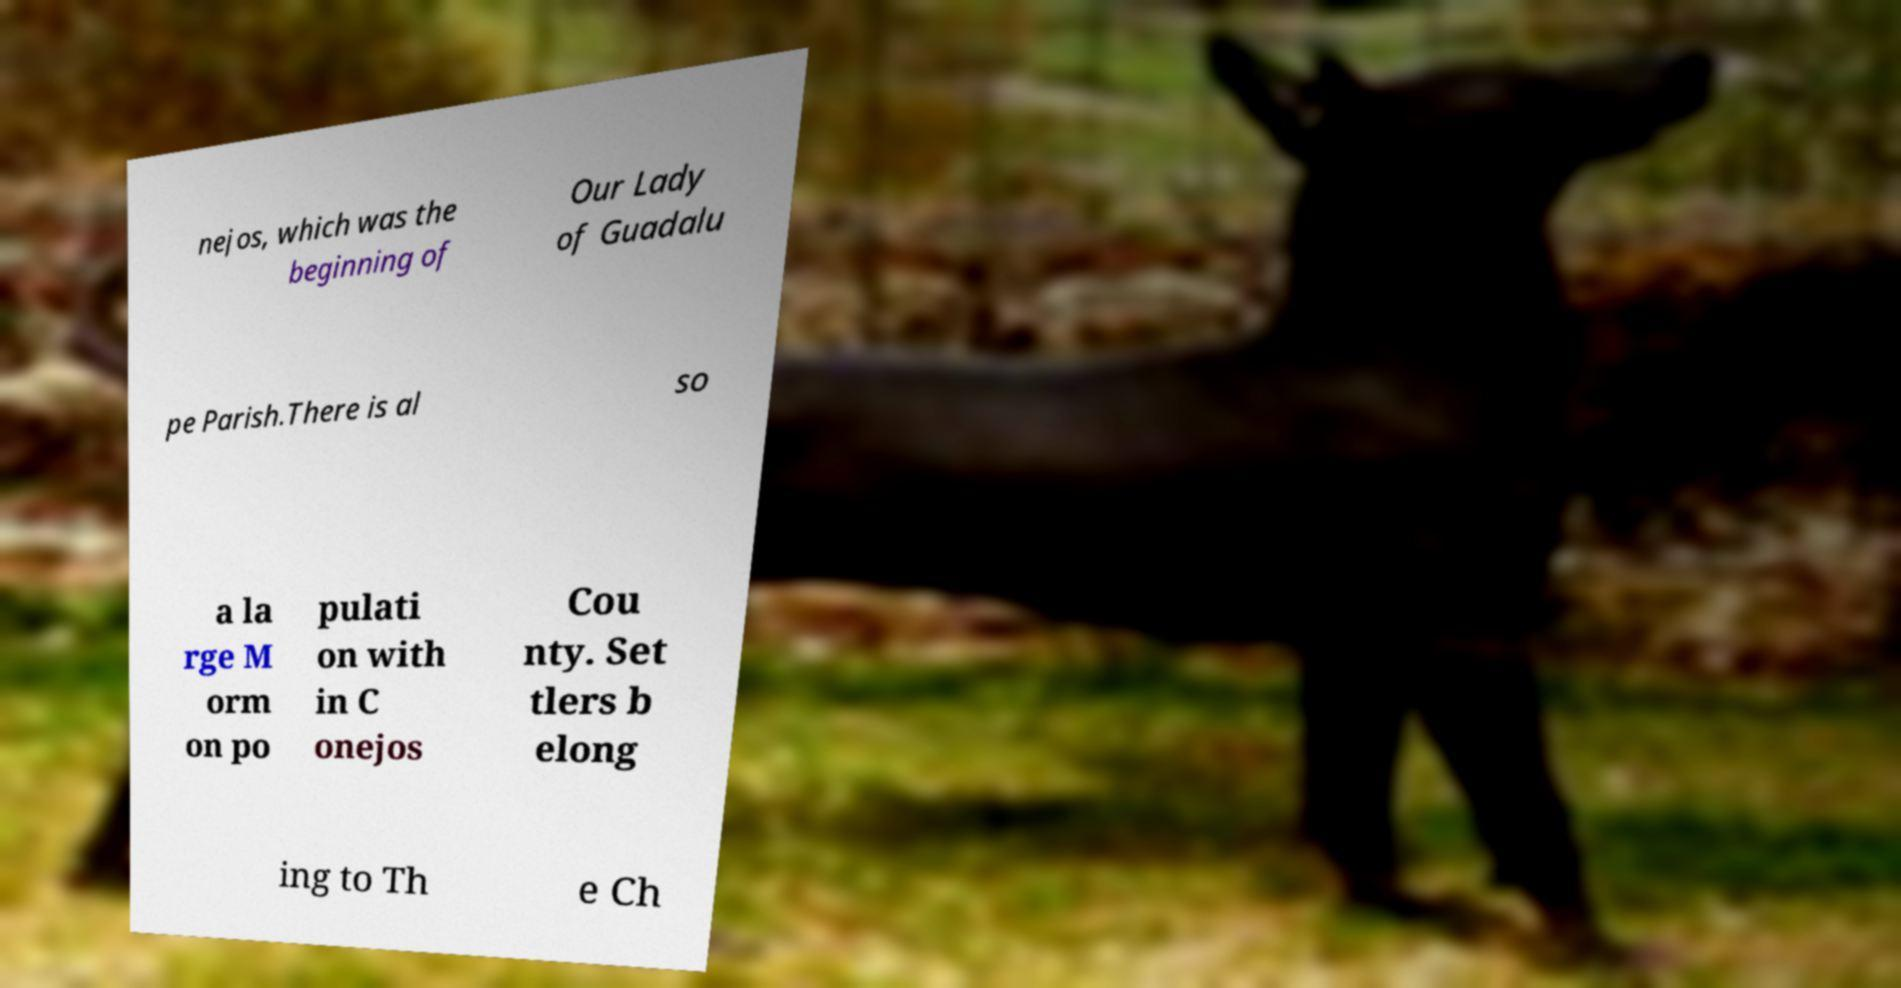Could you extract and type out the text from this image? nejos, which was the beginning of Our Lady of Guadalu pe Parish.There is al so a la rge M orm on po pulati on with in C onejos Cou nty. Set tlers b elong ing to Th e Ch 